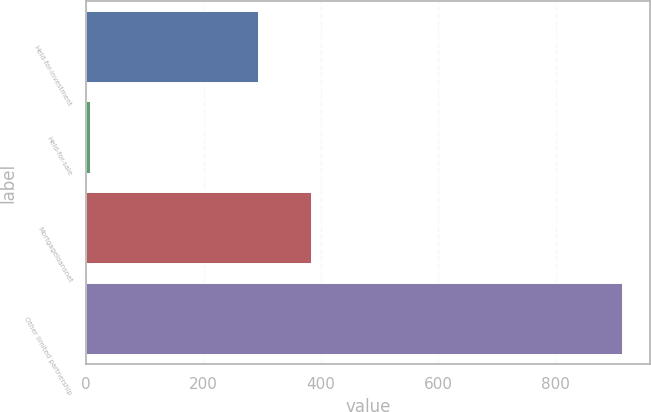Convert chart to OTSL. <chart><loc_0><loc_0><loc_500><loc_500><bar_chart><fcel>Held-for-investment<fcel>Held-for-sale<fcel>Mortgageloansnet<fcel>Other limited partnership<nl><fcel>294<fcel>9<fcel>384.6<fcel>915<nl></chart> 